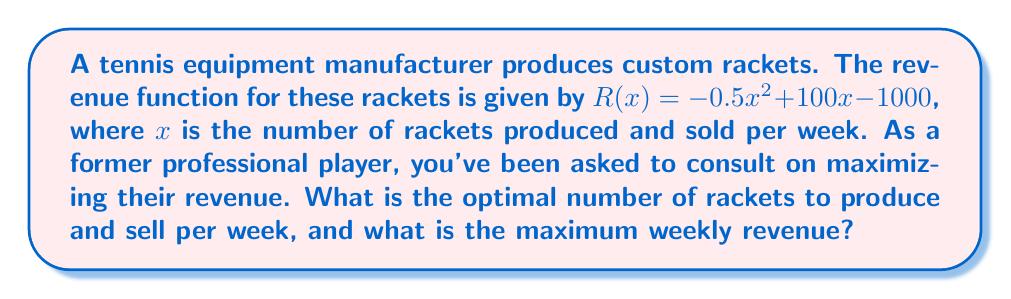Solve this math problem. To find the optimal number of rackets and maximum revenue, we need to follow these steps:

1) The revenue function is given by $R(x) = -0.5x^2 + 100x - 1000$.

2) To maximize revenue, we need to find the critical point where the derivative of $R(x)$ equals zero.

3) Let's find the derivative:
   $R'(x) = -x + 100$

4) Set $R'(x) = 0$ and solve for $x$:
   $-x + 100 = 0$
   $-x = -100$
   $x = 100$

5) The second derivative $R''(x) = -1 < 0$, confirming this critical point is a maximum.

6) To find the maximum revenue, we substitute $x = 100$ into the original revenue function:

   $R(100) = -0.5(100)^2 + 100(100) - 1000$
           $= -5000 + 10000 - 1000$
           $= 4000$

Therefore, the optimal number of rackets to produce and sell is 100 per week, resulting in a maximum weekly revenue of $4000.
Answer: 100 rackets; $4000 